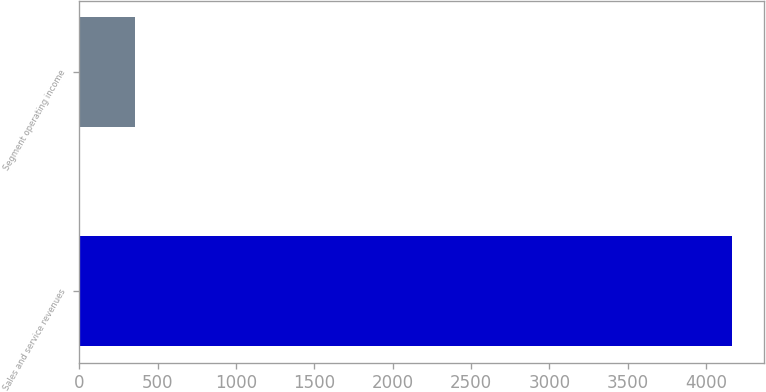Convert chart. <chart><loc_0><loc_0><loc_500><loc_500><bar_chart><fcel>Sales and service revenues<fcel>Segment operating income<nl><fcel>4164<fcel>354<nl></chart> 